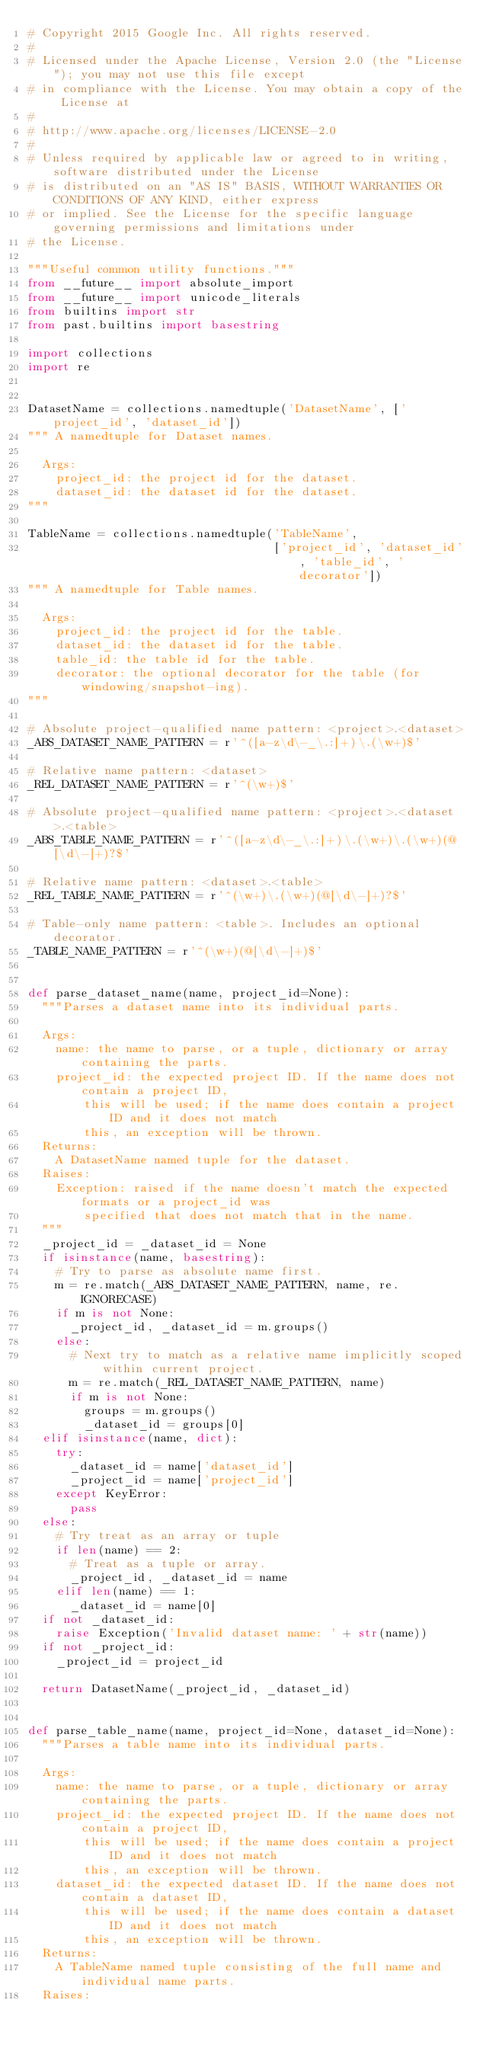Convert code to text. <code><loc_0><loc_0><loc_500><loc_500><_Python_># Copyright 2015 Google Inc. All rights reserved.
#
# Licensed under the Apache License, Version 2.0 (the "License"); you may not use this file except
# in compliance with the License. You may obtain a copy of the License at
#
# http://www.apache.org/licenses/LICENSE-2.0
#
# Unless required by applicable law or agreed to in writing, software distributed under the License
# is distributed on an "AS IS" BASIS, WITHOUT WARRANTIES OR CONDITIONS OF ANY KIND, either express
# or implied. See the License for the specific language governing permissions and limitations under
# the License.

"""Useful common utility functions."""
from __future__ import absolute_import
from __future__ import unicode_literals
from builtins import str
from past.builtins import basestring

import collections
import re


DatasetName = collections.namedtuple('DatasetName', ['project_id', 'dataset_id'])
""" A namedtuple for Dataset names.

  Args:
    project_id: the project id for the dataset.
    dataset_id: the dataset id for the dataset.
"""

TableName = collections.namedtuple('TableName',
                                   ['project_id', 'dataset_id', 'table_id', 'decorator'])
""" A namedtuple for Table names.

  Args:
    project_id: the project id for the table.
    dataset_id: the dataset id for the table.
    table_id: the table id for the table.
    decorator: the optional decorator for the table (for windowing/snapshot-ing).
"""

# Absolute project-qualified name pattern: <project>.<dataset>
_ABS_DATASET_NAME_PATTERN = r'^([a-z\d\-_\.:]+)\.(\w+)$'

# Relative name pattern: <dataset>
_REL_DATASET_NAME_PATTERN = r'^(\w+)$'

# Absolute project-qualified name pattern: <project>.<dataset>.<table>
_ABS_TABLE_NAME_PATTERN = r'^([a-z\d\-_\.:]+)\.(\w+)\.(\w+)(@[\d\-]+)?$'

# Relative name pattern: <dataset>.<table>
_REL_TABLE_NAME_PATTERN = r'^(\w+)\.(\w+)(@[\d\-]+)?$'

# Table-only name pattern: <table>. Includes an optional decorator.
_TABLE_NAME_PATTERN = r'^(\w+)(@[\d\-]+)$'


def parse_dataset_name(name, project_id=None):
  """Parses a dataset name into its individual parts.

  Args:
    name: the name to parse, or a tuple, dictionary or array containing the parts.
    project_id: the expected project ID. If the name does not contain a project ID,
        this will be used; if the name does contain a project ID and it does not match
        this, an exception will be thrown.
  Returns:
    A DatasetName named tuple for the dataset.
  Raises:
    Exception: raised if the name doesn't match the expected formats or a project_id was
        specified that does not match that in the name.
  """
  _project_id = _dataset_id = None
  if isinstance(name, basestring):
    # Try to parse as absolute name first.
    m = re.match(_ABS_DATASET_NAME_PATTERN, name, re.IGNORECASE)
    if m is not None:
      _project_id, _dataset_id = m.groups()
    else:
      # Next try to match as a relative name implicitly scoped within current project.
      m = re.match(_REL_DATASET_NAME_PATTERN, name)
      if m is not None:
        groups = m.groups()
        _dataset_id = groups[0]
  elif isinstance(name, dict):
    try:
      _dataset_id = name['dataset_id']
      _project_id = name['project_id']
    except KeyError:
      pass
  else:
    # Try treat as an array or tuple
    if len(name) == 2:
      # Treat as a tuple or array.
      _project_id, _dataset_id = name
    elif len(name) == 1:
      _dataset_id = name[0]
  if not _dataset_id:
    raise Exception('Invalid dataset name: ' + str(name))
  if not _project_id:
    _project_id = project_id

  return DatasetName(_project_id, _dataset_id)


def parse_table_name(name, project_id=None, dataset_id=None):
  """Parses a table name into its individual parts.

  Args:
    name: the name to parse, or a tuple, dictionary or array containing the parts.
    project_id: the expected project ID. If the name does not contain a project ID,
        this will be used; if the name does contain a project ID and it does not match
        this, an exception will be thrown.
    dataset_id: the expected dataset ID. If the name does not contain a dataset ID,
        this will be used; if the name does contain a dataset ID and it does not match
        this, an exception will be thrown.
  Returns:
    A TableName named tuple consisting of the full name and individual name parts.
  Raises:</code> 